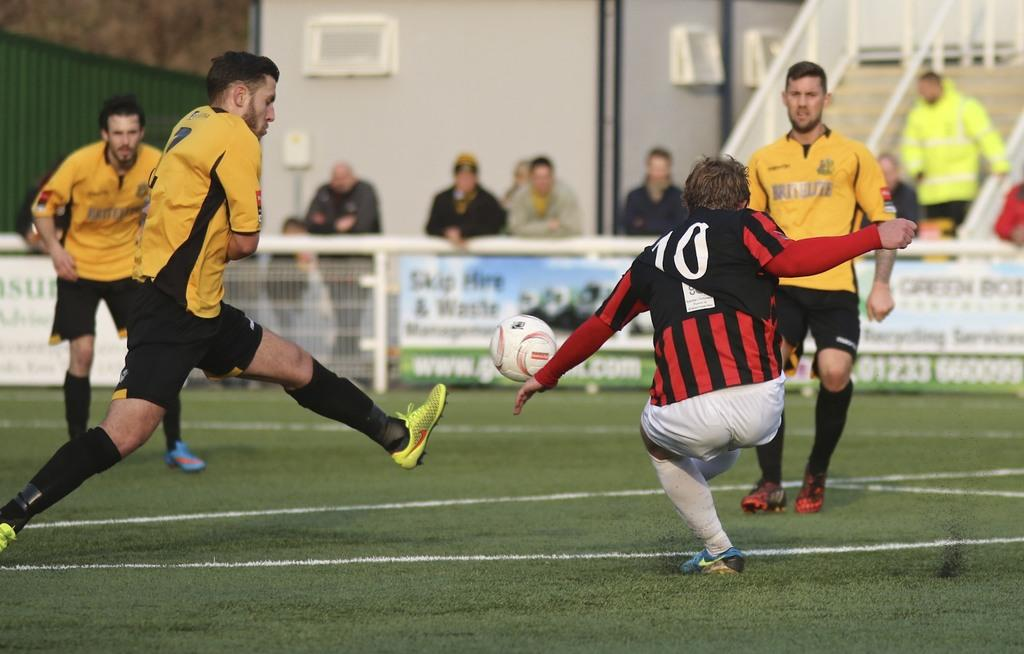How many people are playing football in the image? There are four men in the image who are playing football. What is the setting of the football game? The football game is taking place on a ground. What can be seen in the background of the image? There is a railing in the background of the image, and people are standing behind it. What type of trail can be seen in the image? There is no trail present in the image; it features a football game taking place on a ground. Can you describe the interaction between the men and the ray in the image? There is no ray present in the image; it only shows four men playing football. 